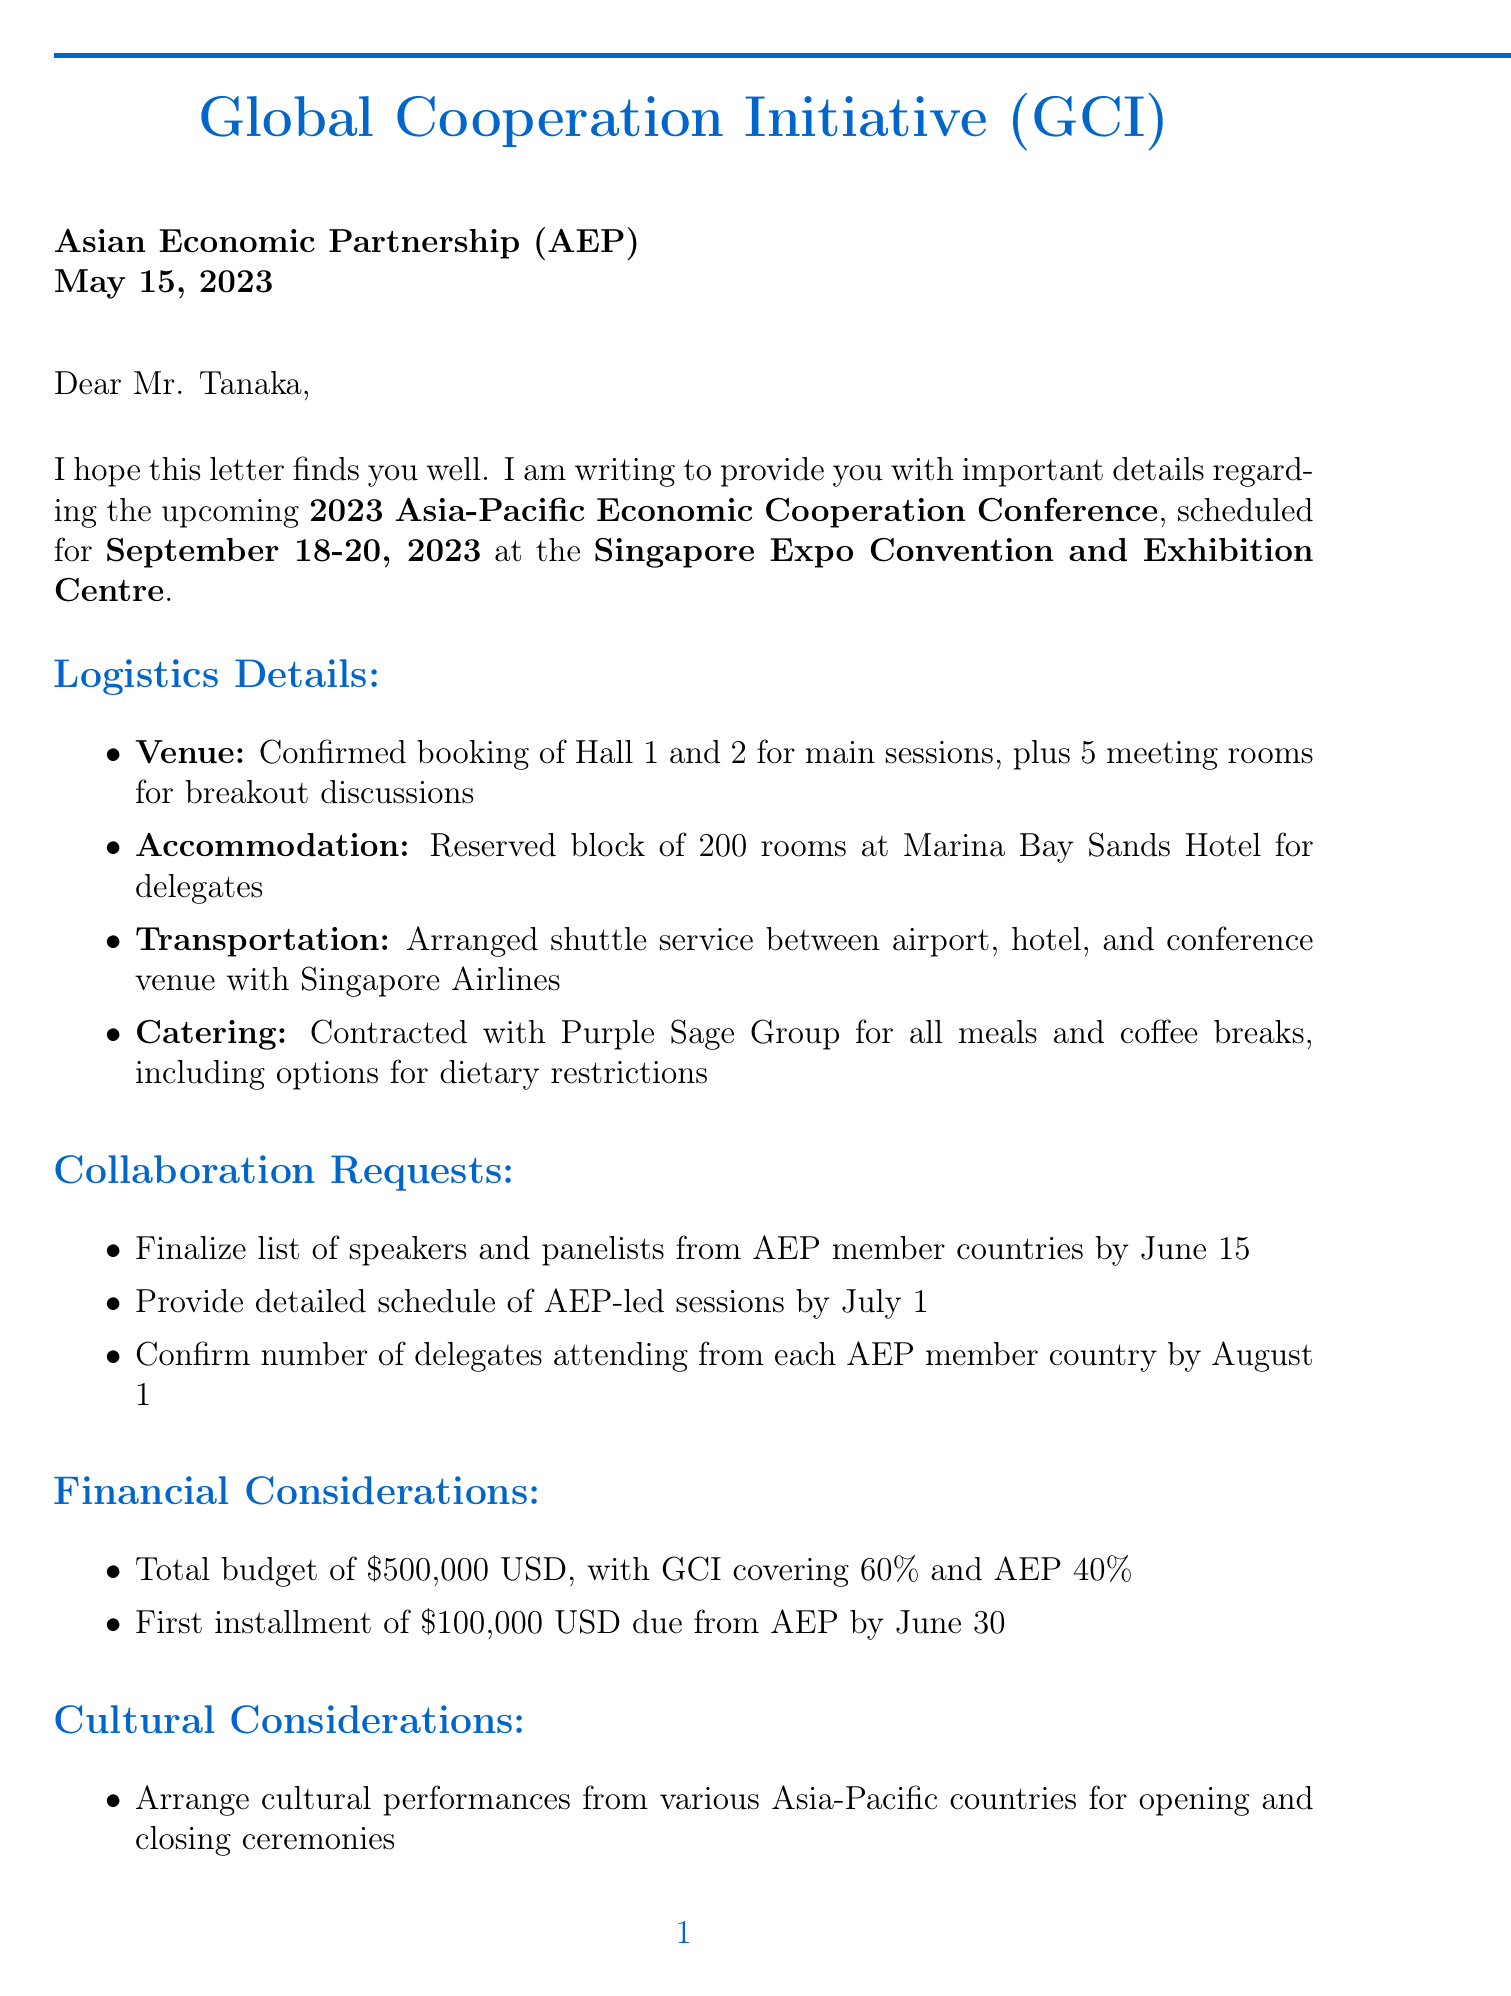What is the name of the event? The event is referred to as the "2023 Asia-Pacific Economic Cooperation Conference" in the introduction section of the letter.
Answer: 2023 Asia-Pacific Economic Cooperation Conference What is the date of the conference? The specific dates for the conference are mentioned in the introduction section.
Answer: September 18-20, 2023 Where is the conference being held? The location of the conference is stated in the introduction.
Answer: Singapore Expo Convention and Exhibition Centre What is the allocated budget for the event? The total budget allocation is detailed in the financial considerations section of the letter.
Answer: $500,000 USD What is the percentage of the budget covered by GCI? The financial considerations provide the percentage that GCI is responsible for.
Answer: 60% By when does AEP need to finalize the list of speakers? The collaboration requests specify the deadline for finalizing the list of speakers from AEP member countries.
Answer: June 15 What services are provided for cultural support during the conference? The cultural considerations section outlines arrangements for cultural performances and multilingual support.
Answer: Cultural performances, multilingual support What is the first installment payment amount due from AEP? The payment schedule specifies the amount of the first installment AEP is responsible for.
Answer: $100,000 USD When is the video conference call scheduled to discuss the conference? The next steps mention the scheduling of a video conference call, including the date.
Answer: May 25 